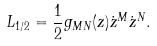<formula> <loc_0><loc_0><loc_500><loc_500>L _ { 1 / 2 } = \frac { 1 } { 2 } g _ { M N } ( z ) \dot { z } ^ { M } \dot { z } ^ { N } .</formula> 